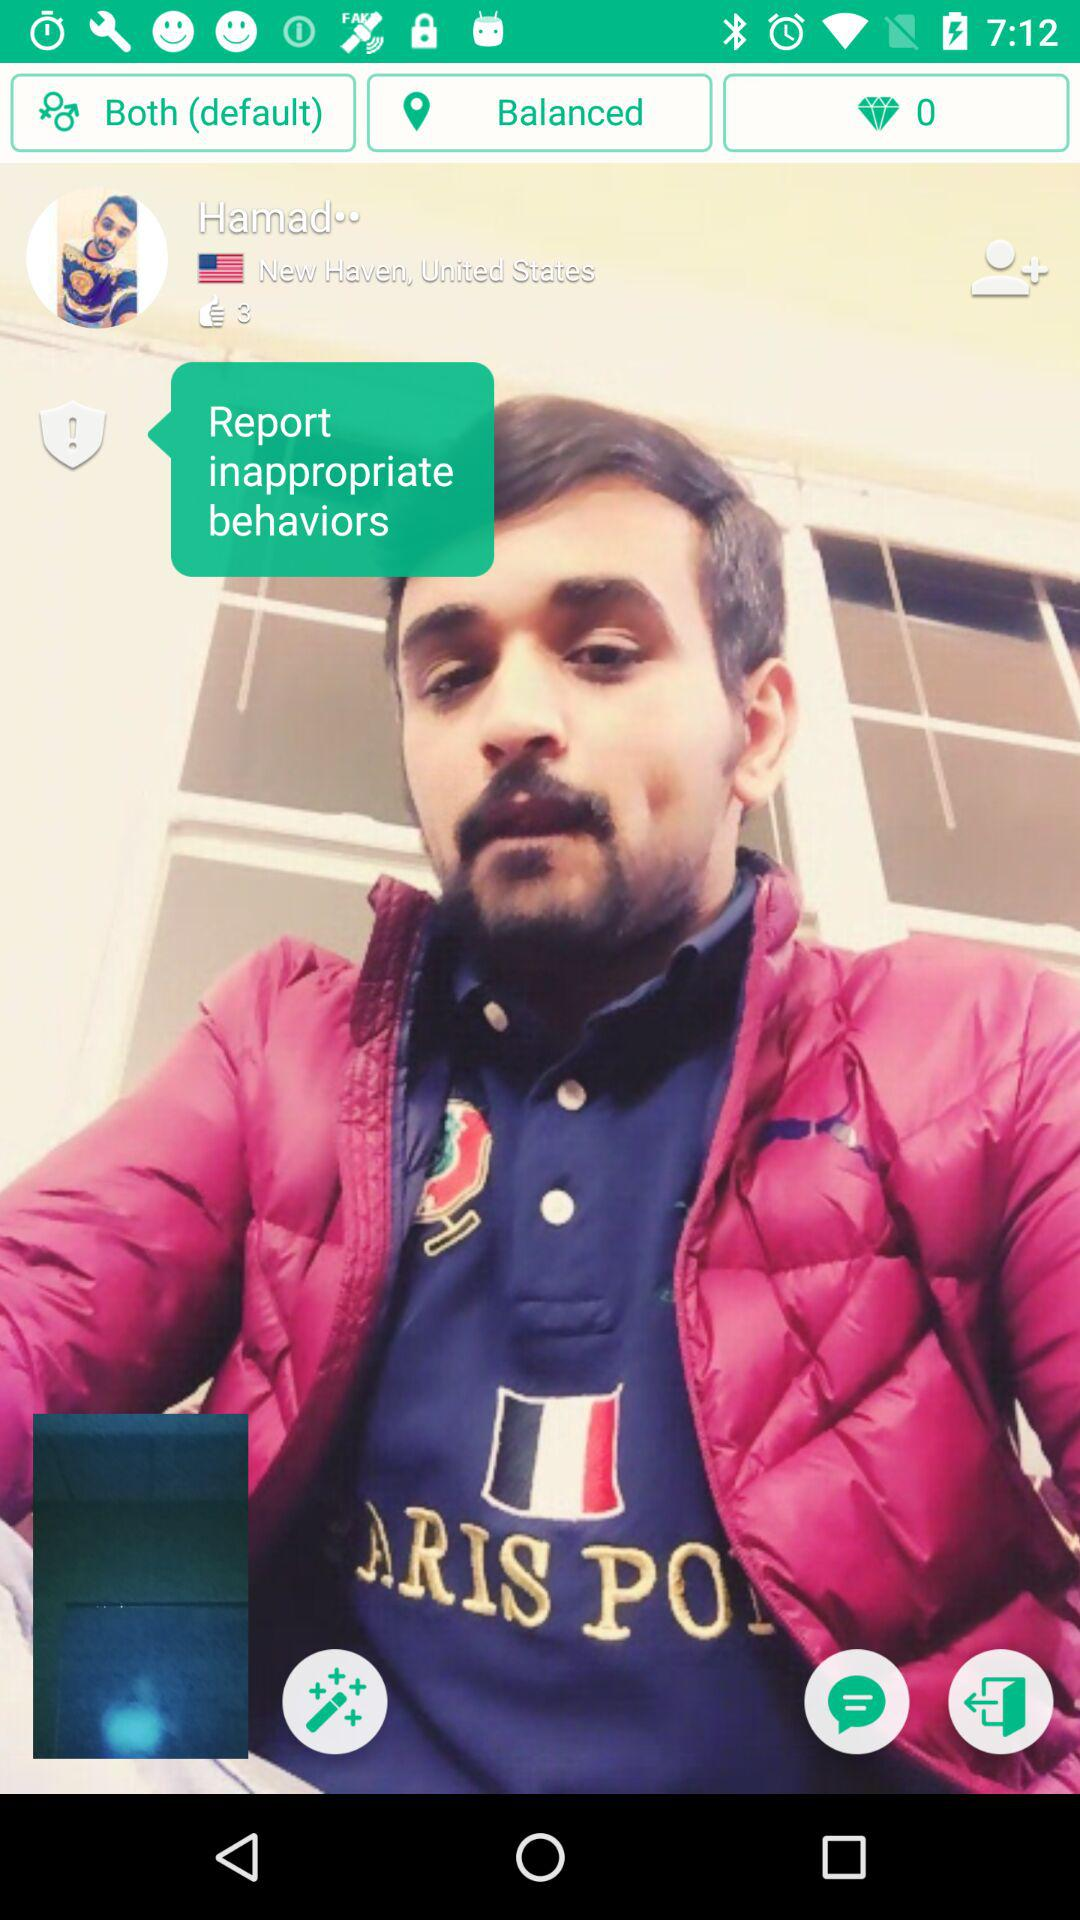How many likes are there on the photo? There are 3 likes. 